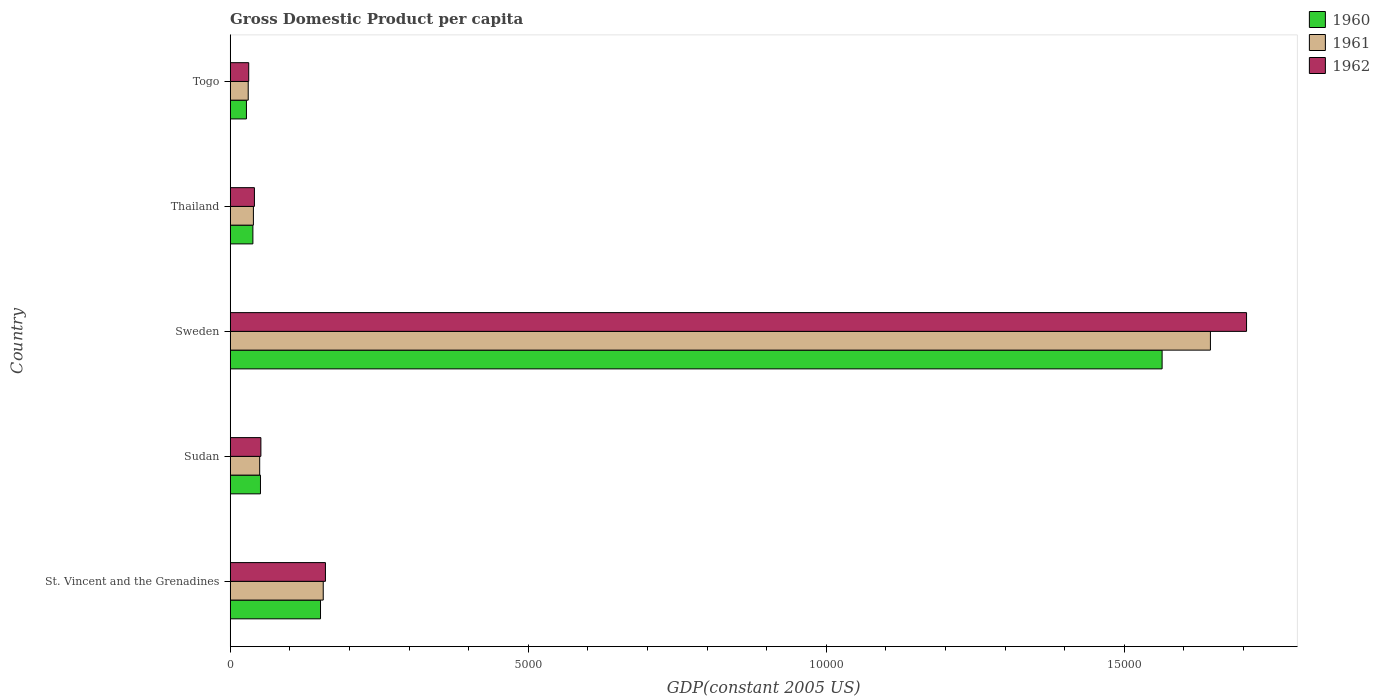How many different coloured bars are there?
Offer a very short reply. 3. Are the number of bars per tick equal to the number of legend labels?
Offer a terse response. Yes. Are the number of bars on each tick of the Y-axis equal?
Offer a terse response. Yes. What is the label of the 4th group of bars from the top?
Your answer should be compact. Sudan. What is the GDP per capita in 1961 in St. Vincent and the Grenadines?
Provide a succinct answer. 1561.03. Across all countries, what is the maximum GDP per capita in 1962?
Offer a very short reply. 1.71e+04. Across all countries, what is the minimum GDP per capita in 1961?
Offer a very short reply. 302.44. In which country was the GDP per capita in 1960 minimum?
Keep it short and to the point. Togo. What is the total GDP per capita in 1962 in the graph?
Ensure brevity in your answer.  1.99e+04. What is the difference between the GDP per capita in 1962 in Sudan and that in Togo?
Make the answer very short. 204.36. What is the difference between the GDP per capita in 1960 in Thailand and the GDP per capita in 1961 in Sudan?
Your answer should be compact. -114.08. What is the average GDP per capita in 1961 per country?
Provide a short and direct response. 3838.72. What is the difference between the GDP per capita in 1962 and GDP per capita in 1960 in Sudan?
Ensure brevity in your answer.  7.27. In how many countries, is the GDP per capita in 1960 greater than 13000 US$?
Provide a succinct answer. 1. What is the ratio of the GDP per capita in 1961 in Sudan to that in Thailand?
Ensure brevity in your answer.  1.27. Is the difference between the GDP per capita in 1962 in Sweden and Togo greater than the difference between the GDP per capita in 1960 in Sweden and Togo?
Offer a terse response. Yes. What is the difference between the highest and the second highest GDP per capita in 1962?
Ensure brevity in your answer.  1.55e+04. What is the difference between the highest and the lowest GDP per capita in 1961?
Provide a short and direct response. 1.61e+04. In how many countries, is the GDP per capita in 1962 greater than the average GDP per capita in 1962 taken over all countries?
Offer a very short reply. 1. Is it the case that in every country, the sum of the GDP per capita in 1962 and GDP per capita in 1961 is greater than the GDP per capita in 1960?
Make the answer very short. Yes. Are the values on the major ticks of X-axis written in scientific E-notation?
Provide a succinct answer. No. Does the graph contain grids?
Provide a succinct answer. No. How many legend labels are there?
Your response must be concise. 3. What is the title of the graph?
Your answer should be very brief. Gross Domestic Product per capita. Does "1975" appear as one of the legend labels in the graph?
Give a very brief answer. No. What is the label or title of the X-axis?
Your response must be concise. GDP(constant 2005 US). What is the label or title of the Y-axis?
Keep it short and to the point. Country. What is the GDP(constant 2005 US) of 1960 in St. Vincent and the Grenadines?
Keep it short and to the point. 1515.48. What is the GDP(constant 2005 US) in 1961 in St. Vincent and the Grenadines?
Your answer should be very brief. 1561.03. What is the GDP(constant 2005 US) of 1962 in St. Vincent and the Grenadines?
Your response must be concise. 1598.04. What is the GDP(constant 2005 US) of 1960 in Sudan?
Your response must be concise. 507.97. What is the GDP(constant 2005 US) of 1961 in Sudan?
Your answer should be very brief. 494.94. What is the GDP(constant 2005 US) of 1962 in Sudan?
Ensure brevity in your answer.  515.24. What is the GDP(constant 2005 US) of 1960 in Sweden?
Keep it short and to the point. 1.56e+04. What is the GDP(constant 2005 US) of 1961 in Sweden?
Your response must be concise. 1.64e+04. What is the GDP(constant 2005 US) in 1962 in Sweden?
Keep it short and to the point. 1.71e+04. What is the GDP(constant 2005 US) in 1960 in Thailand?
Provide a short and direct response. 380.85. What is the GDP(constant 2005 US) in 1961 in Thailand?
Offer a terse response. 389.52. What is the GDP(constant 2005 US) of 1962 in Thailand?
Make the answer very short. 406.6. What is the GDP(constant 2005 US) in 1960 in Togo?
Your answer should be very brief. 272.53. What is the GDP(constant 2005 US) of 1961 in Togo?
Your response must be concise. 302.44. What is the GDP(constant 2005 US) of 1962 in Togo?
Your answer should be compact. 310.89. Across all countries, what is the maximum GDP(constant 2005 US) of 1960?
Your answer should be compact. 1.56e+04. Across all countries, what is the maximum GDP(constant 2005 US) in 1961?
Provide a succinct answer. 1.64e+04. Across all countries, what is the maximum GDP(constant 2005 US) in 1962?
Make the answer very short. 1.71e+04. Across all countries, what is the minimum GDP(constant 2005 US) in 1960?
Give a very brief answer. 272.53. Across all countries, what is the minimum GDP(constant 2005 US) of 1961?
Your response must be concise. 302.44. Across all countries, what is the minimum GDP(constant 2005 US) in 1962?
Give a very brief answer. 310.89. What is the total GDP(constant 2005 US) in 1960 in the graph?
Your answer should be compact. 1.83e+04. What is the total GDP(constant 2005 US) of 1961 in the graph?
Your response must be concise. 1.92e+04. What is the total GDP(constant 2005 US) in 1962 in the graph?
Ensure brevity in your answer.  1.99e+04. What is the difference between the GDP(constant 2005 US) of 1960 in St. Vincent and the Grenadines and that in Sudan?
Give a very brief answer. 1007.51. What is the difference between the GDP(constant 2005 US) of 1961 in St. Vincent and the Grenadines and that in Sudan?
Your answer should be compact. 1066.09. What is the difference between the GDP(constant 2005 US) of 1962 in St. Vincent and the Grenadines and that in Sudan?
Your answer should be compact. 1082.79. What is the difference between the GDP(constant 2005 US) of 1960 in St. Vincent and the Grenadines and that in Sweden?
Keep it short and to the point. -1.41e+04. What is the difference between the GDP(constant 2005 US) of 1961 in St. Vincent and the Grenadines and that in Sweden?
Give a very brief answer. -1.49e+04. What is the difference between the GDP(constant 2005 US) of 1962 in St. Vincent and the Grenadines and that in Sweden?
Offer a very short reply. -1.55e+04. What is the difference between the GDP(constant 2005 US) of 1960 in St. Vincent and the Grenadines and that in Thailand?
Keep it short and to the point. 1134.63. What is the difference between the GDP(constant 2005 US) of 1961 in St. Vincent and the Grenadines and that in Thailand?
Offer a very short reply. 1171.51. What is the difference between the GDP(constant 2005 US) in 1962 in St. Vincent and the Grenadines and that in Thailand?
Offer a terse response. 1191.44. What is the difference between the GDP(constant 2005 US) of 1960 in St. Vincent and the Grenadines and that in Togo?
Give a very brief answer. 1242.95. What is the difference between the GDP(constant 2005 US) in 1961 in St. Vincent and the Grenadines and that in Togo?
Ensure brevity in your answer.  1258.59. What is the difference between the GDP(constant 2005 US) of 1962 in St. Vincent and the Grenadines and that in Togo?
Ensure brevity in your answer.  1287.15. What is the difference between the GDP(constant 2005 US) of 1960 in Sudan and that in Sweden?
Provide a succinct answer. -1.51e+04. What is the difference between the GDP(constant 2005 US) in 1961 in Sudan and that in Sweden?
Offer a very short reply. -1.60e+04. What is the difference between the GDP(constant 2005 US) of 1962 in Sudan and that in Sweden?
Your answer should be compact. -1.65e+04. What is the difference between the GDP(constant 2005 US) in 1960 in Sudan and that in Thailand?
Keep it short and to the point. 127.12. What is the difference between the GDP(constant 2005 US) in 1961 in Sudan and that in Thailand?
Your answer should be compact. 105.42. What is the difference between the GDP(constant 2005 US) in 1962 in Sudan and that in Thailand?
Give a very brief answer. 108.64. What is the difference between the GDP(constant 2005 US) of 1960 in Sudan and that in Togo?
Offer a very short reply. 235.45. What is the difference between the GDP(constant 2005 US) in 1961 in Sudan and that in Togo?
Provide a succinct answer. 192.5. What is the difference between the GDP(constant 2005 US) in 1962 in Sudan and that in Togo?
Your answer should be compact. 204.36. What is the difference between the GDP(constant 2005 US) in 1960 in Sweden and that in Thailand?
Keep it short and to the point. 1.53e+04. What is the difference between the GDP(constant 2005 US) of 1961 in Sweden and that in Thailand?
Give a very brief answer. 1.61e+04. What is the difference between the GDP(constant 2005 US) of 1962 in Sweden and that in Thailand?
Offer a very short reply. 1.66e+04. What is the difference between the GDP(constant 2005 US) in 1960 in Sweden and that in Togo?
Ensure brevity in your answer.  1.54e+04. What is the difference between the GDP(constant 2005 US) in 1961 in Sweden and that in Togo?
Ensure brevity in your answer.  1.61e+04. What is the difference between the GDP(constant 2005 US) of 1962 in Sweden and that in Togo?
Offer a terse response. 1.67e+04. What is the difference between the GDP(constant 2005 US) in 1960 in Thailand and that in Togo?
Provide a succinct answer. 108.32. What is the difference between the GDP(constant 2005 US) of 1961 in Thailand and that in Togo?
Keep it short and to the point. 87.08. What is the difference between the GDP(constant 2005 US) of 1962 in Thailand and that in Togo?
Make the answer very short. 95.71. What is the difference between the GDP(constant 2005 US) in 1960 in St. Vincent and the Grenadines and the GDP(constant 2005 US) in 1961 in Sudan?
Give a very brief answer. 1020.54. What is the difference between the GDP(constant 2005 US) of 1960 in St. Vincent and the Grenadines and the GDP(constant 2005 US) of 1962 in Sudan?
Your answer should be very brief. 1000.24. What is the difference between the GDP(constant 2005 US) in 1961 in St. Vincent and the Grenadines and the GDP(constant 2005 US) in 1962 in Sudan?
Make the answer very short. 1045.78. What is the difference between the GDP(constant 2005 US) in 1960 in St. Vincent and the Grenadines and the GDP(constant 2005 US) in 1961 in Sweden?
Your answer should be very brief. -1.49e+04. What is the difference between the GDP(constant 2005 US) in 1960 in St. Vincent and the Grenadines and the GDP(constant 2005 US) in 1962 in Sweden?
Ensure brevity in your answer.  -1.55e+04. What is the difference between the GDP(constant 2005 US) of 1961 in St. Vincent and the Grenadines and the GDP(constant 2005 US) of 1962 in Sweden?
Keep it short and to the point. -1.55e+04. What is the difference between the GDP(constant 2005 US) of 1960 in St. Vincent and the Grenadines and the GDP(constant 2005 US) of 1961 in Thailand?
Offer a terse response. 1125.96. What is the difference between the GDP(constant 2005 US) of 1960 in St. Vincent and the Grenadines and the GDP(constant 2005 US) of 1962 in Thailand?
Keep it short and to the point. 1108.88. What is the difference between the GDP(constant 2005 US) of 1961 in St. Vincent and the Grenadines and the GDP(constant 2005 US) of 1962 in Thailand?
Your answer should be compact. 1154.43. What is the difference between the GDP(constant 2005 US) of 1960 in St. Vincent and the Grenadines and the GDP(constant 2005 US) of 1961 in Togo?
Your response must be concise. 1213.04. What is the difference between the GDP(constant 2005 US) in 1960 in St. Vincent and the Grenadines and the GDP(constant 2005 US) in 1962 in Togo?
Give a very brief answer. 1204.6. What is the difference between the GDP(constant 2005 US) of 1961 in St. Vincent and the Grenadines and the GDP(constant 2005 US) of 1962 in Togo?
Your response must be concise. 1250.14. What is the difference between the GDP(constant 2005 US) in 1960 in Sudan and the GDP(constant 2005 US) in 1961 in Sweden?
Ensure brevity in your answer.  -1.59e+04. What is the difference between the GDP(constant 2005 US) in 1960 in Sudan and the GDP(constant 2005 US) in 1962 in Sweden?
Provide a succinct answer. -1.65e+04. What is the difference between the GDP(constant 2005 US) in 1961 in Sudan and the GDP(constant 2005 US) in 1962 in Sweden?
Ensure brevity in your answer.  -1.66e+04. What is the difference between the GDP(constant 2005 US) in 1960 in Sudan and the GDP(constant 2005 US) in 1961 in Thailand?
Keep it short and to the point. 118.46. What is the difference between the GDP(constant 2005 US) in 1960 in Sudan and the GDP(constant 2005 US) in 1962 in Thailand?
Your answer should be compact. 101.38. What is the difference between the GDP(constant 2005 US) in 1961 in Sudan and the GDP(constant 2005 US) in 1962 in Thailand?
Your answer should be compact. 88.34. What is the difference between the GDP(constant 2005 US) in 1960 in Sudan and the GDP(constant 2005 US) in 1961 in Togo?
Offer a very short reply. 205.54. What is the difference between the GDP(constant 2005 US) of 1960 in Sudan and the GDP(constant 2005 US) of 1962 in Togo?
Ensure brevity in your answer.  197.09. What is the difference between the GDP(constant 2005 US) in 1961 in Sudan and the GDP(constant 2005 US) in 1962 in Togo?
Offer a very short reply. 184.05. What is the difference between the GDP(constant 2005 US) in 1960 in Sweden and the GDP(constant 2005 US) in 1961 in Thailand?
Make the answer very short. 1.52e+04. What is the difference between the GDP(constant 2005 US) in 1960 in Sweden and the GDP(constant 2005 US) in 1962 in Thailand?
Your answer should be very brief. 1.52e+04. What is the difference between the GDP(constant 2005 US) in 1961 in Sweden and the GDP(constant 2005 US) in 1962 in Thailand?
Offer a very short reply. 1.60e+04. What is the difference between the GDP(constant 2005 US) of 1960 in Sweden and the GDP(constant 2005 US) of 1961 in Togo?
Give a very brief answer. 1.53e+04. What is the difference between the GDP(constant 2005 US) in 1960 in Sweden and the GDP(constant 2005 US) in 1962 in Togo?
Give a very brief answer. 1.53e+04. What is the difference between the GDP(constant 2005 US) of 1961 in Sweden and the GDP(constant 2005 US) of 1962 in Togo?
Keep it short and to the point. 1.61e+04. What is the difference between the GDP(constant 2005 US) in 1960 in Thailand and the GDP(constant 2005 US) in 1961 in Togo?
Offer a very short reply. 78.42. What is the difference between the GDP(constant 2005 US) in 1960 in Thailand and the GDP(constant 2005 US) in 1962 in Togo?
Give a very brief answer. 69.97. What is the difference between the GDP(constant 2005 US) in 1961 in Thailand and the GDP(constant 2005 US) in 1962 in Togo?
Offer a terse response. 78.63. What is the average GDP(constant 2005 US) in 1960 per country?
Offer a very short reply. 3662.38. What is the average GDP(constant 2005 US) in 1961 per country?
Your answer should be compact. 3838.72. What is the average GDP(constant 2005 US) in 1962 per country?
Offer a very short reply. 3976.51. What is the difference between the GDP(constant 2005 US) of 1960 and GDP(constant 2005 US) of 1961 in St. Vincent and the Grenadines?
Provide a succinct answer. -45.55. What is the difference between the GDP(constant 2005 US) of 1960 and GDP(constant 2005 US) of 1962 in St. Vincent and the Grenadines?
Your response must be concise. -82.55. What is the difference between the GDP(constant 2005 US) of 1961 and GDP(constant 2005 US) of 1962 in St. Vincent and the Grenadines?
Offer a terse response. -37.01. What is the difference between the GDP(constant 2005 US) of 1960 and GDP(constant 2005 US) of 1961 in Sudan?
Give a very brief answer. 13.04. What is the difference between the GDP(constant 2005 US) in 1960 and GDP(constant 2005 US) in 1962 in Sudan?
Ensure brevity in your answer.  -7.27. What is the difference between the GDP(constant 2005 US) in 1961 and GDP(constant 2005 US) in 1962 in Sudan?
Provide a short and direct response. -20.31. What is the difference between the GDP(constant 2005 US) in 1960 and GDP(constant 2005 US) in 1961 in Sweden?
Provide a short and direct response. -810.66. What is the difference between the GDP(constant 2005 US) in 1960 and GDP(constant 2005 US) in 1962 in Sweden?
Give a very brief answer. -1416.73. What is the difference between the GDP(constant 2005 US) in 1961 and GDP(constant 2005 US) in 1962 in Sweden?
Offer a very short reply. -606.08. What is the difference between the GDP(constant 2005 US) of 1960 and GDP(constant 2005 US) of 1961 in Thailand?
Your answer should be compact. -8.66. What is the difference between the GDP(constant 2005 US) of 1960 and GDP(constant 2005 US) of 1962 in Thailand?
Give a very brief answer. -25.75. What is the difference between the GDP(constant 2005 US) of 1961 and GDP(constant 2005 US) of 1962 in Thailand?
Give a very brief answer. -17.08. What is the difference between the GDP(constant 2005 US) of 1960 and GDP(constant 2005 US) of 1961 in Togo?
Provide a succinct answer. -29.91. What is the difference between the GDP(constant 2005 US) in 1960 and GDP(constant 2005 US) in 1962 in Togo?
Your answer should be very brief. -38.36. What is the difference between the GDP(constant 2005 US) in 1961 and GDP(constant 2005 US) in 1962 in Togo?
Ensure brevity in your answer.  -8.45. What is the ratio of the GDP(constant 2005 US) of 1960 in St. Vincent and the Grenadines to that in Sudan?
Provide a short and direct response. 2.98. What is the ratio of the GDP(constant 2005 US) of 1961 in St. Vincent and the Grenadines to that in Sudan?
Your response must be concise. 3.15. What is the ratio of the GDP(constant 2005 US) of 1962 in St. Vincent and the Grenadines to that in Sudan?
Give a very brief answer. 3.1. What is the ratio of the GDP(constant 2005 US) in 1960 in St. Vincent and the Grenadines to that in Sweden?
Your response must be concise. 0.1. What is the ratio of the GDP(constant 2005 US) in 1961 in St. Vincent and the Grenadines to that in Sweden?
Provide a succinct answer. 0.09. What is the ratio of the GDP(constant 2005 US) of 1962 in St. Vincent and the Grenadines to that in Sweden?
Keep it short and to the point. 0.09. What is the ratio of the GDP(constant 2005 US) of 1960 in St. Vincent and the Grenadines to that in Thailand?
Your answer should be very brief. 3.98. What is the ratio of the GDP(constant 2005 US) in 1961 in St. Vincent and the Grenadines to that in Thailand?
Keep it short and to the point. 4.01. What is the ratio of the GDP(constant 2005 US) of 1962 in St. Vincent and the Grenadines to that in Thailand?
Keep it short and to the point. 3.93. What is the ratio of the GDP(constant 2005 US) of 1960 in St. Vincent and the Grenadines to that in Togo?
Provide a succinct answer. 5.56. What is the ratio of the GDP(constant 2005 US) in 1961 in St. Vincent and the Grenadines to that in Togo?
Offer a terse response. 5.16. What is the ratio of the GDP(constant 2005 US) of 1962 in St. Vincent and the Grenadines to that in Togo?
Keep it short and to the point. 5.14. What is the ratio of the GDP(constant 2005 US) of 1960 in Sudan to that in Sweden?
Offer a terse response. 0.03. What is the ratio of the GDP(constant 2005 US) of 1961 in Sudan to that in Sweden?
Your answer should be compact. 0.03. What is the ratio of the GDP(constant 2005 US) of 1962 in Sudan to that in Sweden?
Make the answer very short. 0.03. What is the ratio of the GDP(constant 2005 US) in 1960 in Sudan to that in Thailand?
Provide a short and direct response. 1.33. What is the ratio of the GDP(constant 2005 US) in 1961 in Sudan to that in Thailand?
Provide a short and direct response. 1.27. What is the ratio of the GDP(constant 2005 US) of 1962 in Sudan to that in Thailand?
Make the answer very short. 1.27. What is the ratio of the GDP(constant 2005 US) in 1960 in Sudan to that in Togo?
Your answer should be compact. 1.86. What is the ratio of the GDP(constant 2005 US) of 1961 in Sudan to that in Togo?
Offer a terse response. 1.64. What is the ratio of the GDP(constant 2005 US) of 1962 in Sudan to that in Togo?
Your answer should be compact. 1.66. What is the ratio of the GDP(constant 2005 US) in 1960 in Sweden to that in Thailand?
Your answer should be compact. 41.05. What is the ratio of the GDP(constant 2005 US) in 1961 in Sweden to that in Thailand?
Offer a terse response. 42.22. What is the ratio of the GDP(constant 2005 US) of 1962 in Sweden to that in Thailand?
Keep it short and to the point. 41.94. What is the ratio of the GDP(constant 2005 US) of 1960 in Sweden to that in Togo?
Ensure brevity in your answer.  57.37. What is the ratio of the GDP(constant 2005 US) of 1961 in Sweden to that in Togo?
Offer a terse response. 54.38. What is the ratio of the GDP(constant 2005 US) in 1962 in Sweden to that in Togo?
Your response must be concise. 54.85. What is the ratio of the GDP(constant 2005 US) in 1960 in Thailand to that in Togo?
Offer a terse response. 1.4. What is the ratio of the GDP(constant 2005 US) in 1961 in Thailand to that in Togo?
Your answer should be compact. 1.29. What is the ratio of the GDP(constant 2005 US) of 1962 in Thailand to that in Togo?
Make the answer very short. 1.31. What is the difference between the highest and the second highest GDP(constant 2005 US) of 1960?
Your answer should be very brief. 1.41e+04. What is the difference between the highest and the second highest GDP(constant 2005 US) in 1961?
Your answer should be very brief. 1.49e+04. What is the difference between the highest and the second highest GDP(constant 2005 US) of 1962?
Offer a terse response. 1.55e+04. What is the difference between the highest and the lowest GDP(constant 2005 US) in 1960?
Your response must be concise. 1.54e+04. What is the difference between the highest and the lowest GDP(constant 2005 US) of 1961?
Provide a succinct answer. 1.61e+04. What is the difference between the highest and the lowest GDP(constant 2005 US) in 1962?
Give a very brief answer. 1.67e+04. 